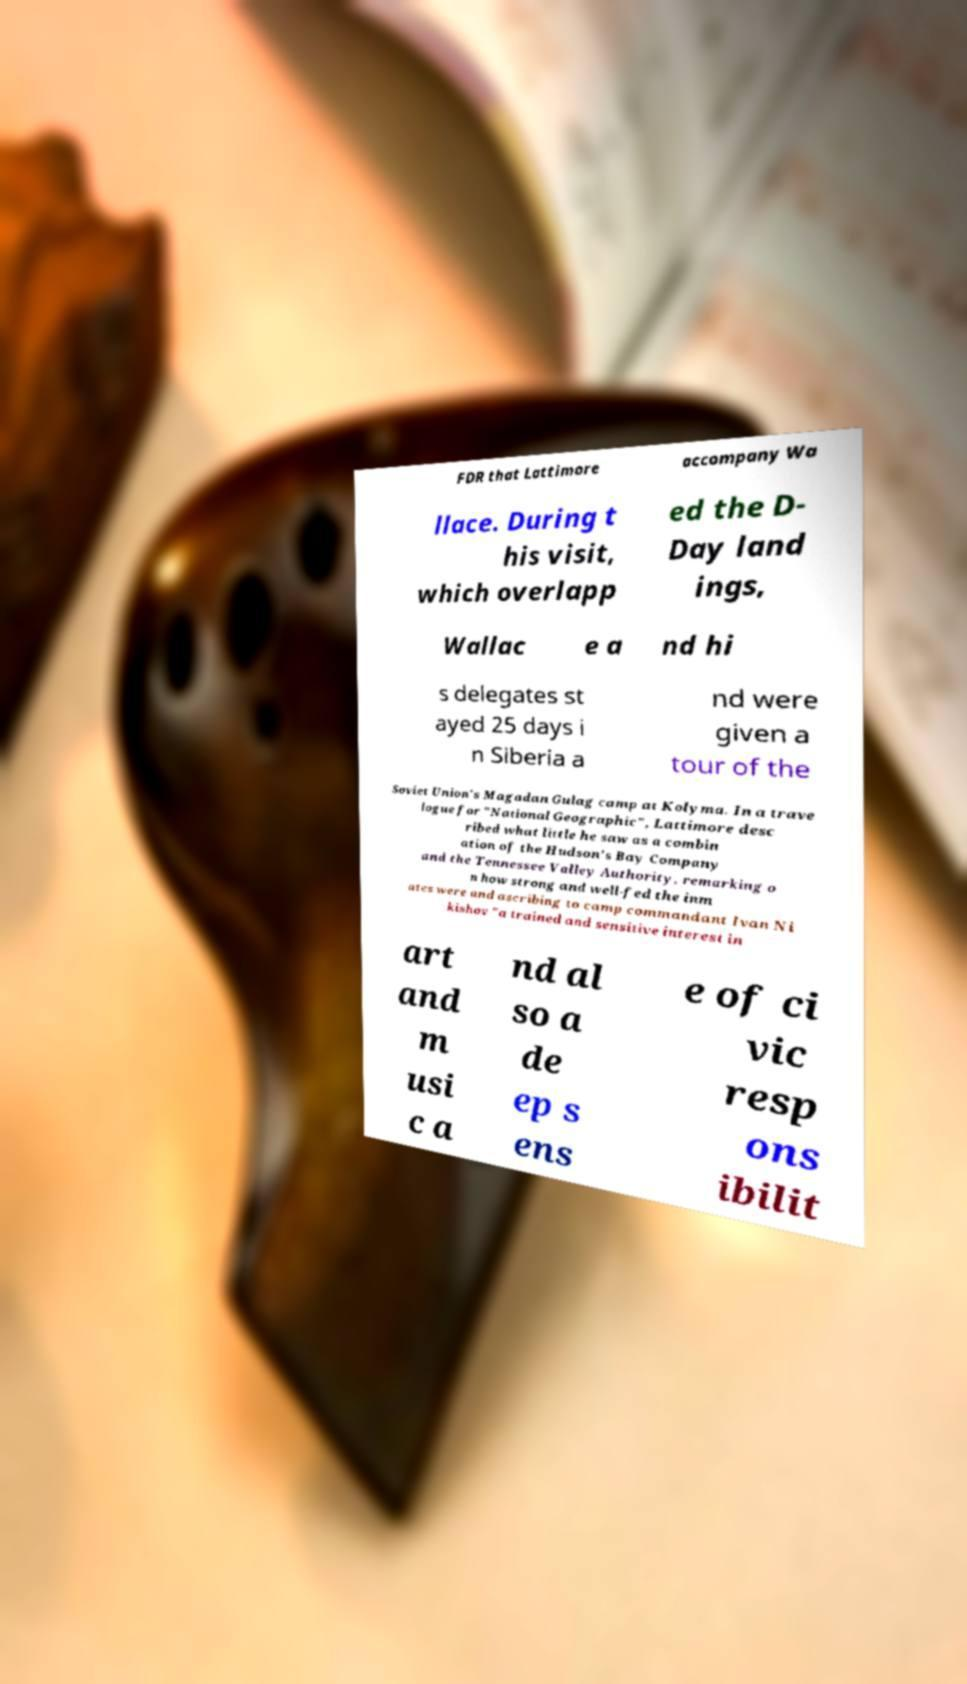For documentation purposes, I need the text within this image transcribed. Could you provide that? FDR that Lattimore accompany Wa llace. During t his visit, which overlapp ed the D- Day land ings, Wallac e a nd hi s delegates st ayed 25 days i n Siberia a nd were given a tour of the Soviet Union's Magadan Gulag camp at Kolyma. In a trave logue for "National Geographic", Lattimore desc ribed what little he saw as a combin ation of the Hudson's Bay Company and the Tennessee Valley Authority, remarking o n how strong and well-fed the inm ates were and ascribing to camp commandant Ivan Ni kishov "a trained and sensitive interest in art and m usi c a nd al so a de ep s ens e of ci vic resp ons ibilit 